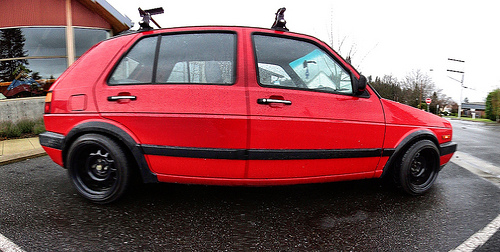<image>
Can you confirm if the window is on the car? No. The window is not positioned on the car. They may be near each other, but the window is not supported by or resting on top of the car. 